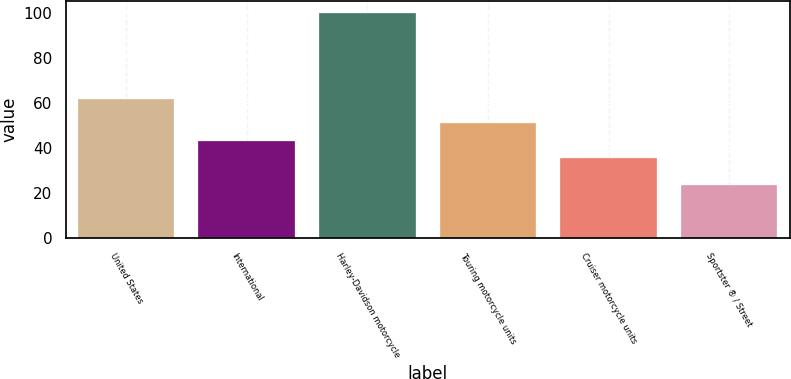<chart> <loc_0><loc_0><loc_500><loc_500><bar_chart><fcel>United States<fcel>International<fcel>Harley-Davidson motorcycle<fcel>Touring motorcycle units<fcel>Cruiser motorcycle units<fcel>Sportster ® / Street<nl><fcel>61.7<fcel>43.26<fcel>100<fcel>50.92<fcel>35.6<fcel>23.4<nl></chart> 